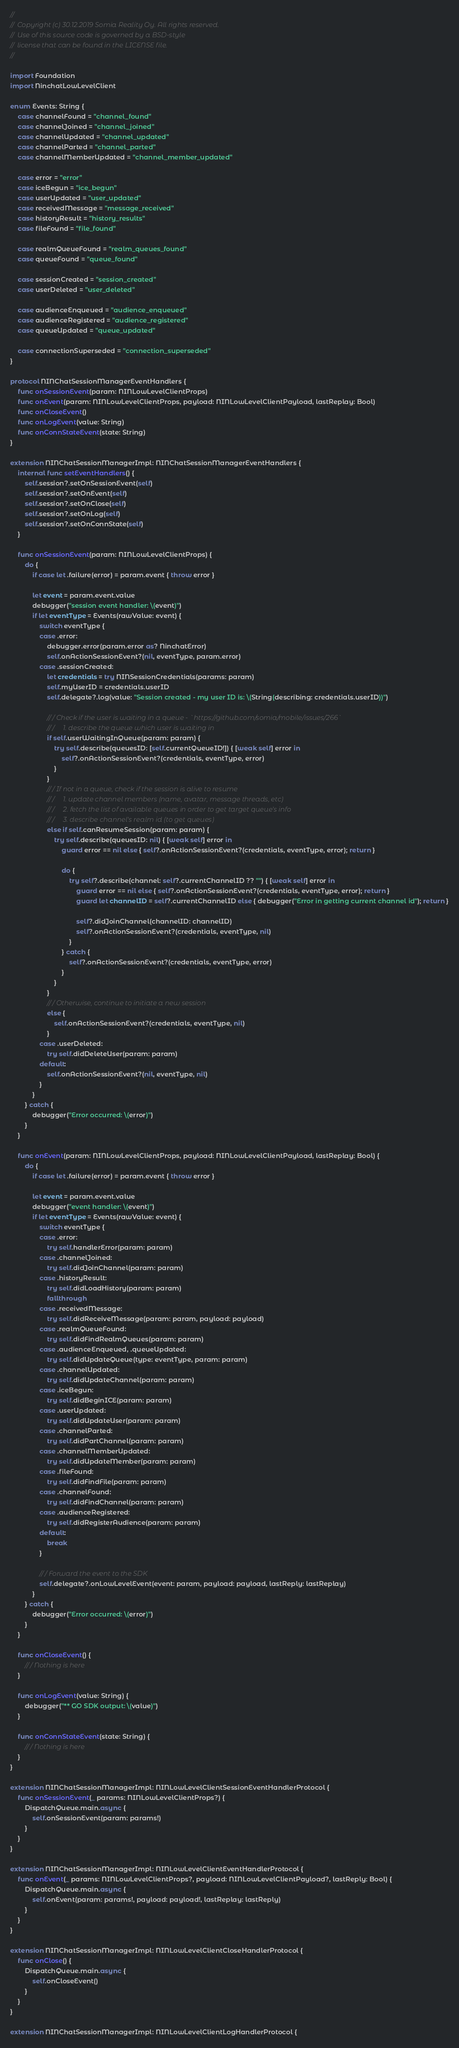<code> <loc_0><loc_0><loc_500><loc_500><_Swift_>//
// Copyright (c) 30.12.2019 Somia Reality Oy. All rights reserved.
// Use of this source code is governed by a BSD-style
// license that can be found in the LICENSE file.
//

import Foundation
import NinchatLowLevelClient

enum Events: String {
    case channelFound = "channel_found"
    case channelJoined = "channel_joined"
    case channelUpdated = "channel_updated"
    case channelParted = "channel_parted"
    case channelMemberUpdated = "channel_member_updated"
    
    case error = "error"
    case iceBegun = "ice_begun"
    case userUpdated = "user_updated"
    case receivedMessage = "message_received"
    case historyResult = "history_results"
    case fileFound = "file_found"

    case realmQueueFound = "realm_queues_found"
    case queueFound = "queue_found"
    
    case sessionCreated = "session_created"
    case userDeleted = "user_deleted"
    
    case audienceEnqueued = "audience_enqueued"
    case audienceRegistered = "audience_registered"
    case queueUpdated = "queue_updated"

    case connectionSuperseded = "connection_superseded"
}

protocol NINChatSessionManagerEventHandlers {
    func onSessionEvent(param: NINLowLevelClientProps)
    func onEvent(param: NINLowLevelClientProps, payload: NINLowLevelClientPayload, lastReplay: Bool)
    func onCloseEvent()
    func onLogEvent(value: String)
    func onConnStateEvent(state: String)
}

extension NINChatSessionManagerImpl: NINChatSessionManagerEventHandlers {
    internal func setEventHandlers() {
        self.session?.setOnSessionEvent(self)
        self.session?.setOnEvent(self)
        self.session?.setOnClose(self)
        self.session?.setOnLog(self)
        self.session?.setOnConnState(self)
    }
    
    func onSessionEvent(param: NINLowLevelClientProps) {
        do {
            if case let .failure(error) = param.event { throw error }

            let event = param.event.value
            debugger("session event handler: \(event)")
            if let eventType = Events(rawValue: event) {
                switch eventType {
                case .error:
                    debugger.error(param.error as? NinchatError)
                    self.onActionSessionEvent?(nil, eventType, param.error)
                case .sessionCreated:
                    let credentials = try NINSessionCredentials(params: param)
                    self.myUserID = credentials.userID
                    self.delegate?.log(value: "Session created - my user ID is: \(String(describing: credentials.userID))")

                    /// Check if the user is waiting in a queue - `https://github.com/somia/mobile/issues/266`
                    ///     1. describe the queue which user is waiting in
                    if self.userWaitingInQueue(param: param) {
                        try self.describe(queuesID: [self.currentQueueID!]) { [weak self] error in
                            self?.onActionSessionEvent?(credentials, eventType, error)
                        }
                    }
                    /// If not in a queue, check if the session is alive to resume
                    ///     1. update channel members (name, avatar, message threads, etc)
                    ///     2. fetch the list of available queues in order to get target queue's info
                    ///     3. describe channel's realm id (to get queues)
                    else if self.canResumeSession(param: param) {
                        try self.describe(queuesID: nil) { [weak self] error in
                            guard error == nil else { self?.onActionSessionEvent?(credentials, eventType, error); return }

                            do {
                                try self?.describe(channel: self?.currentChannelID ?? "") { [weak self] error in
                                    guard error == nil else { self?.onActionSessionEvent?(credentials, eventType, error); return }
                                    guard let channelID = self?.currentChannelID else { debugger("Error in getting current channel id"); return }

                                    self?.didJoinChannel(channelID: channelID)
                                    self?.onActionSessionEvent?(credentials, eventType, nil)
                                }
                            } catch {
                                self?.onActionSessionEvent?(credentials, eventType, error)
                            }
                        }
                    }
                    /// Otherwise, continue to initiate a new session
                    else {
                        self.onActionSessionEvent?(credentials, eventType, nil)
                    }
                case .userDeleted:
                    try self.didDeleteUser(param: param)
                default:
                    self.onActionSessionEvent?(nil, eventType, nil)
                }
            }
        } catch {
            debugger("Error occurred: \(error)")
        }
    }

    func onEvent(param: NINLowLevelClientProps, payload: NINLowLevelClientPayload, lastReplay: Bool) {
        do {
            if case let .failure(error) = param.event { throw error }

            let event = param.event.value
            debugger("event handler: \(event)")
            if let eventType = Events(rawValue: event) {
                switch eventType {
                case .error:
                    try self.handlerError(param: param)
                case .channelJoined:
                    try self.didJoinChannel(param: param)
                case .historyResult:
                    try self.didLoadHistory(param: param)
                    fallthrough
                case .receivedMessage:
                    try self.didReceiveMessage(param: param, payload: payload)
                case .realmQueueFound:
                    try self.didFindRealmQueues(param: param)
                case .audienceEnqueued, .queueUpdated:
                    try self.didUpdateQueue(type: eventType, param: param)
                case .channelUpdated:
                    try self.didUpdateChannel(param: param)
                case .iceBegun:
                    try self.didBeginICE(param: param)
                case .userUpdated:
                    try self.didUpdateUser(param: param)
                case .channelParted:
                    try self.didPartChannel(param: param)
                case .channelMemberUpdated:
                    try self.didUpdateMember(param: param)
                case .fileFound:
                    try self.didFindFile(param: param)
                case .channelFound:
                    try self.didFindChannel(param: param)
                case .audienceRegistered:
                    try self.didRegisterAudience(param: param)
                default:
                    break
                }
                
                /// Forward the event to the SDK
                self.delegate?.onLowLevelEvent(event: param, payload: payload, lastReply: lastReplay)
            }
        } catch {
            debugger("Error occurred: \(error)")
        }
    }
    
    func onCloseEvent() {
        /// Nothing is here
    }
    
    func onLogEvent(value: String) {
        debugger("** GO SDK output: \(value)")
    }
    
    func onConnStateEvent(state: String) {
        /// Nothing is here
    }
}

extension NINChatSessionManagerImpl: NINLowLevelClientSessionEventHandlerProtocol {
    func onSessionEvent(_ params: NINLowLevelClientProps?) {
        DispatchQueue.main.async {
            self.onSessionEvent(param: params!)
        }
    }
}

extension NINChatSessionManagerImpl: NINLowLevelClientEventHandlerProtocol {
    func onEvent(_ params: NINLowLevelClientProps?, payload: NINLowLevelClientPayload?, lastReply: Bool) {
        DispatchQueue.main.async {
            self.onEvent(param: params!, payload: payload!, lastReplay: lastReply)
        }
    }
}

extension NINChatSessionManagerImpl: NINLowLevelClientCloseHandlerProtocol {
    func onClose() {
        DispatchQueue.main.async {
            self.onCloseEvent()
        }
    }
}

extension NINChatSessionManagerImpl: NINLowLevelClientLogHandlerProtocol {</code> 